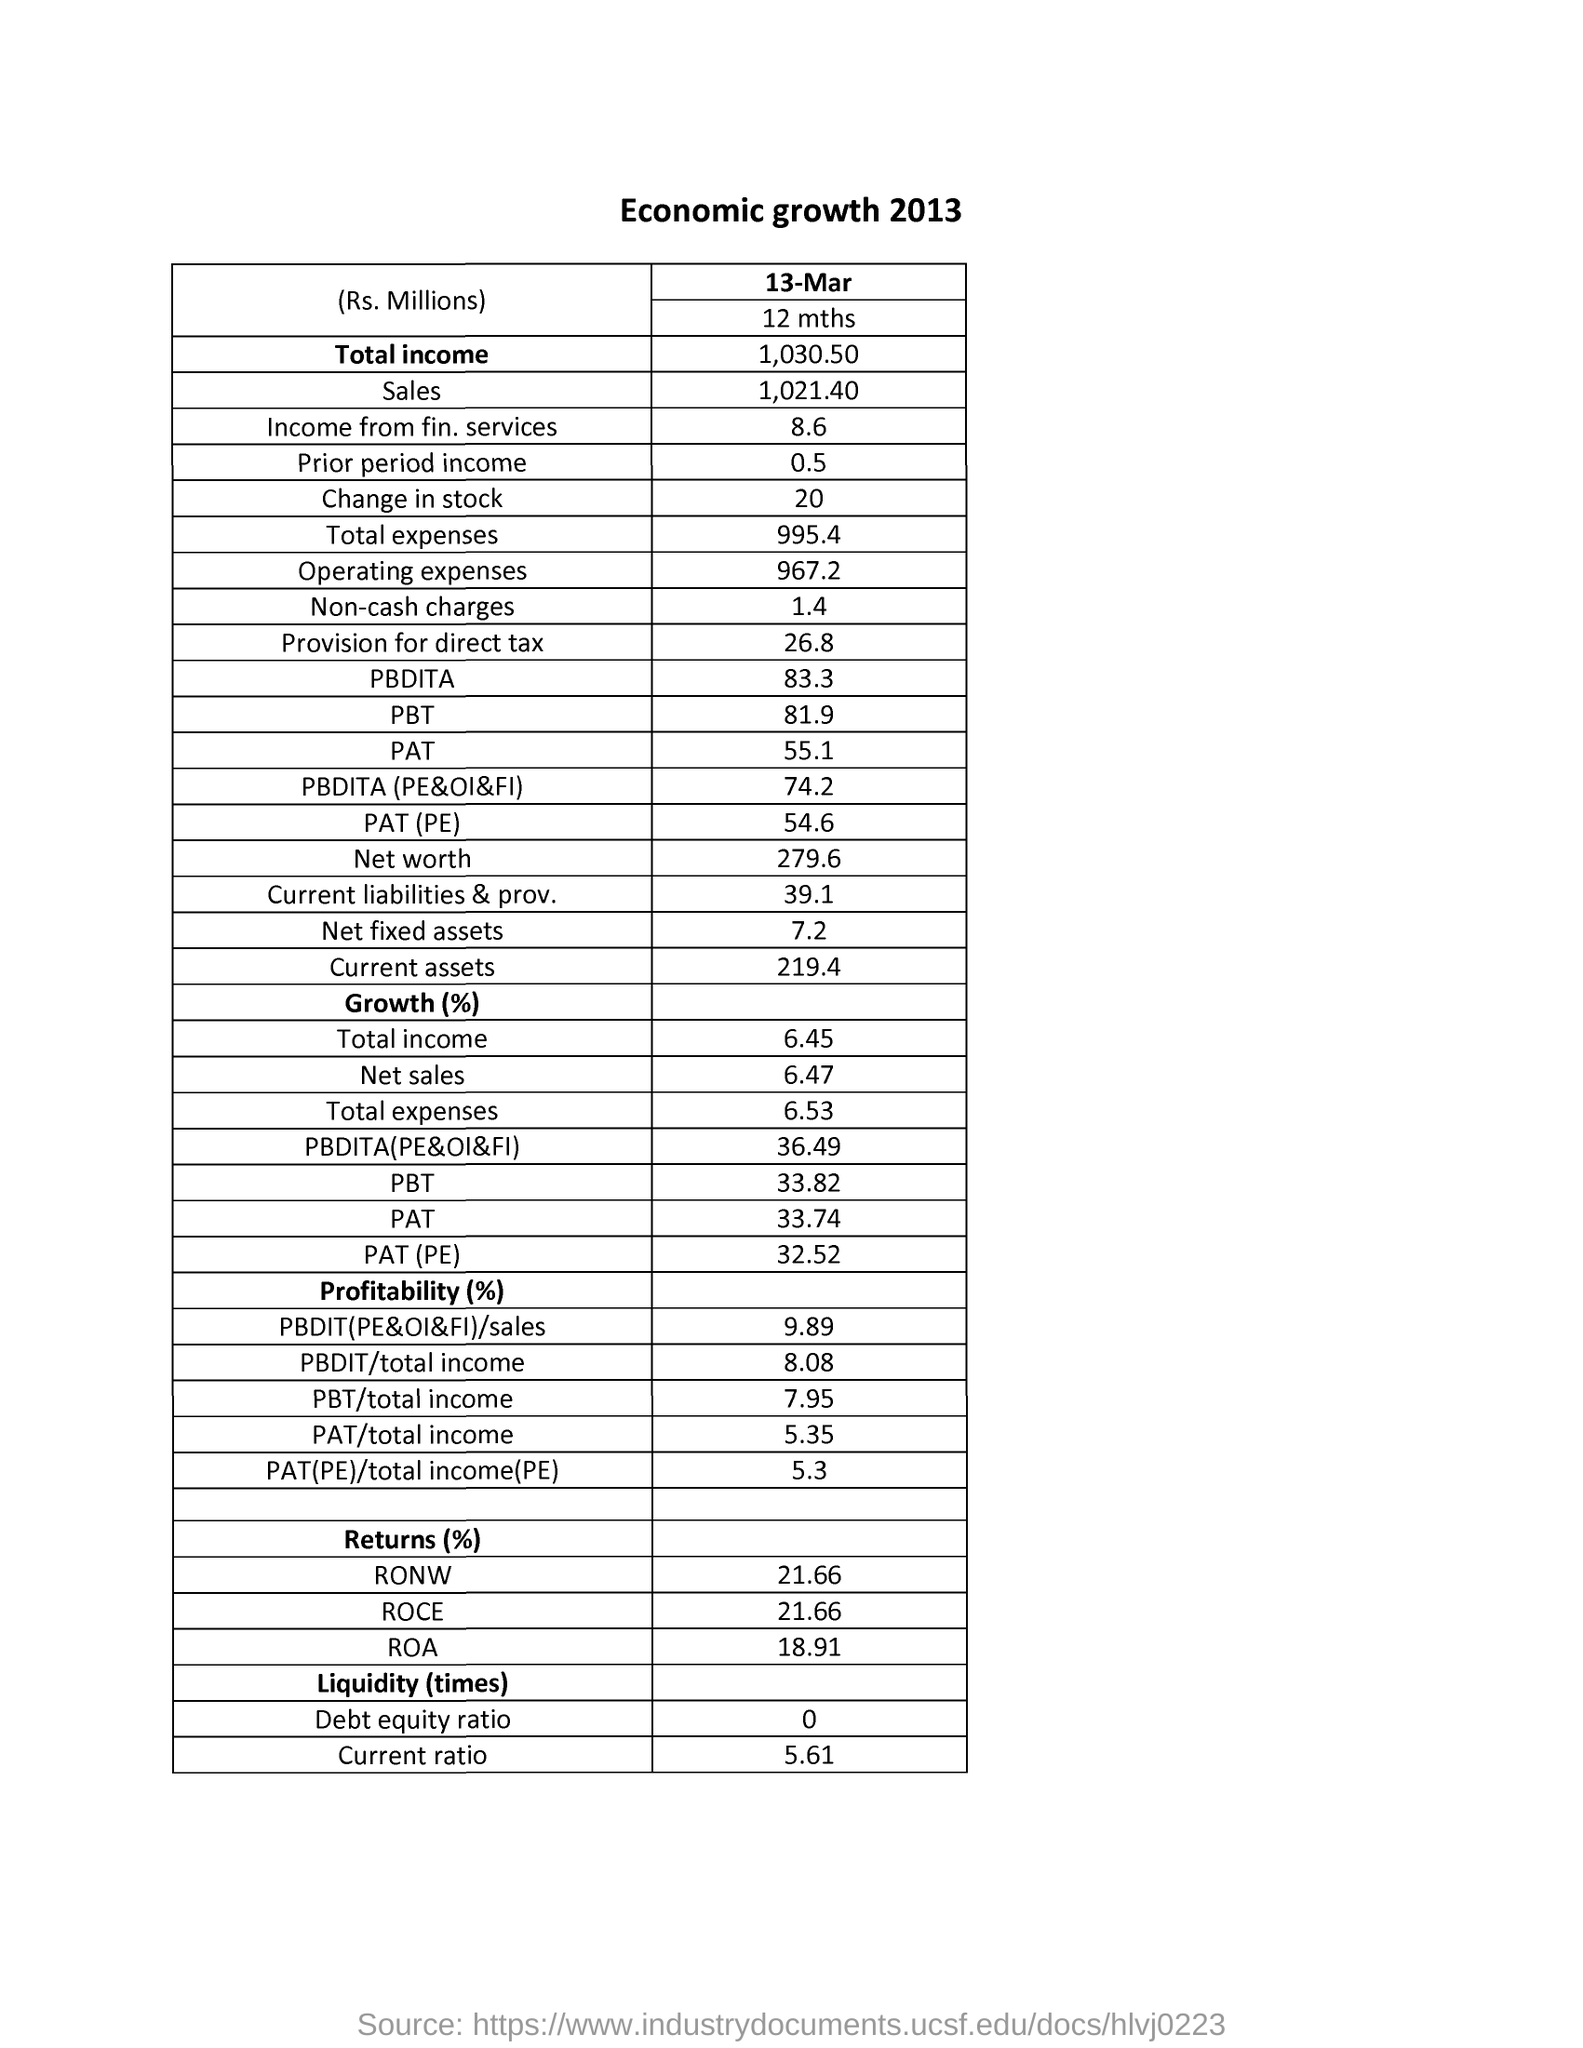Give some essential details in this illustration. The return on capital employed (ROCE) is 21.66%. The income from financial services is approximately 8.6 lakhs in Indian rupees. The total income is 1,030.50 rupees. 